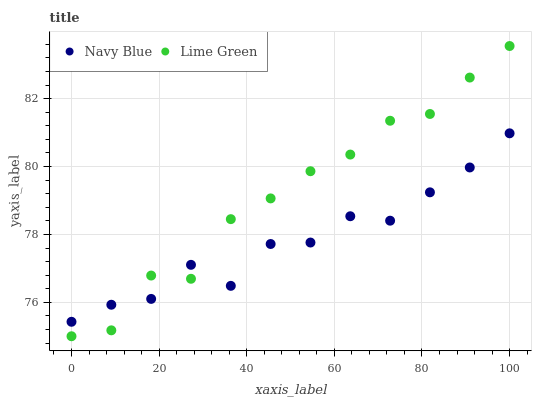Does Navy Blue have the minimum area under the curve?
Answer yes or no. Yes. Does Lime Green have the maximum area under the curve?
Answer yes or no. Yes. Does Lime Green have the minimum area under the curve?
Answer yes or no. No. Is Navy Blue the smoothest?
Answer yes or no. Yes. Is Lime Green the roughest?
Answer yes or no. Yes. Is Lime Green the smoothest?
Answer yes or no. No. Does Lime Green have the lowest value?
Answer yes or no. Yes. Does Lime Green have the highest value?
Answer yes or no. Yes. Does Lime Green intersect Navy Blue?
Answer yes or no. Yes. Is Lime Green less than Navy Blue?
Answer yes or no. No. Is Lime Green greater than Navy Blue?
Answer yes or no. No. 